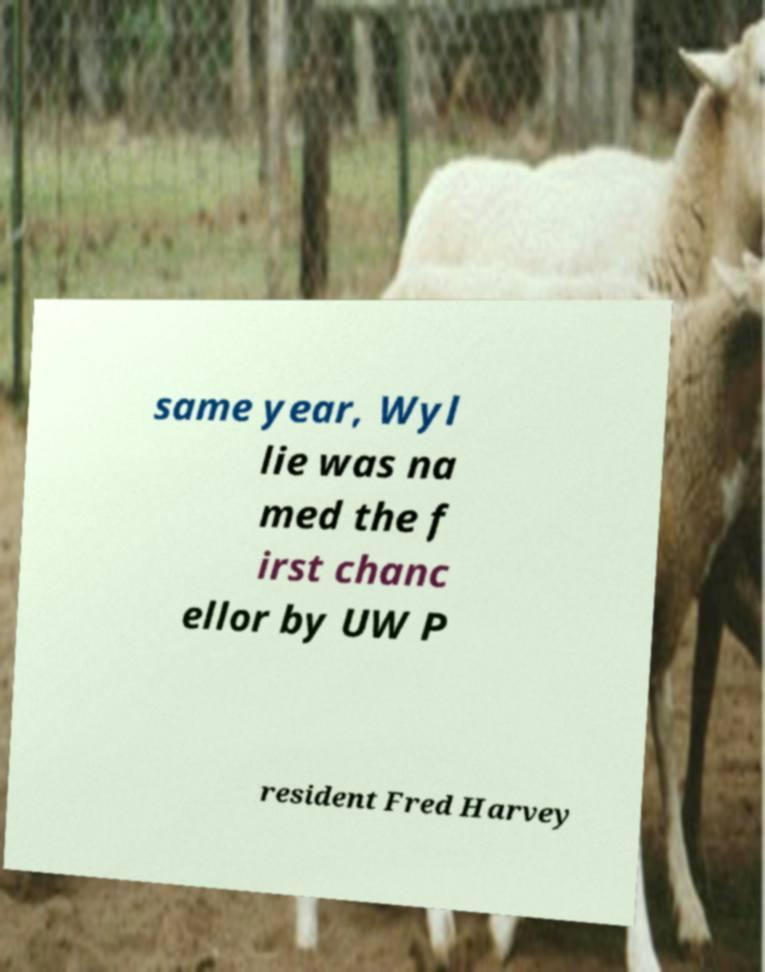Could you extract and type out the text from this image? same year, Wyl lie was na med the f irst chanc ellor by UW P resident Fred Harvey 